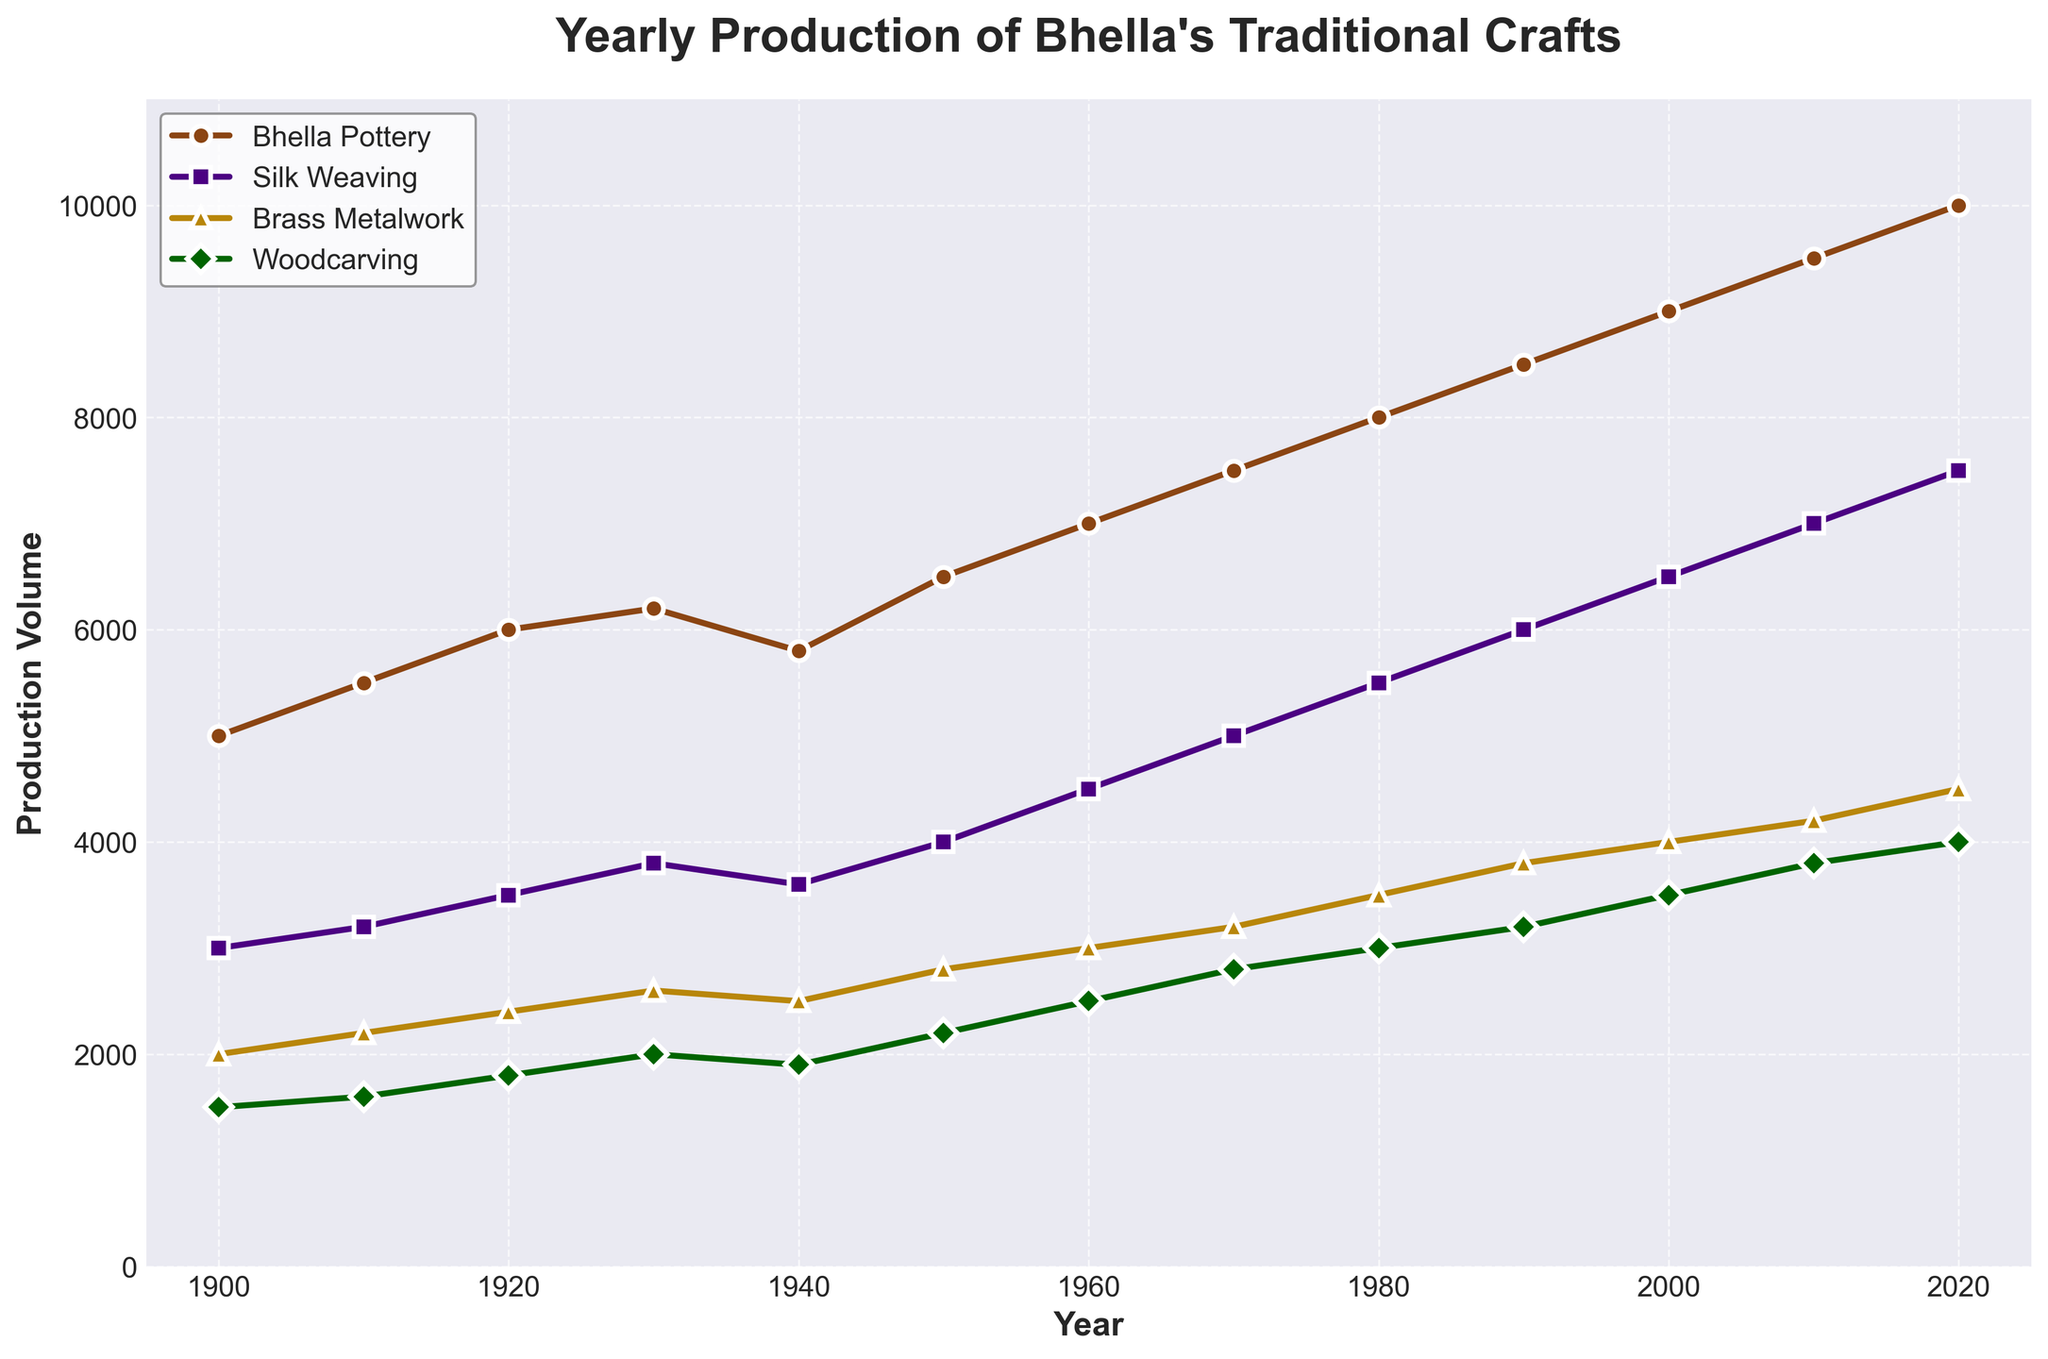How has the production volume of Bhella Pottery changed from 1900 to 2020? To find this, look at the Bhella Pottery data points for the years 1900 and 2020. In 1900, the production volume is 5,000, while in 2020, it is 10,000. Thus, it has doubled over 120 years.
Answer: It has doubled Which traditional craft had the highest production volume in 2020? To answer this, observe the data points in 2020 for all the crafts. Bhella Pottery (10,000) is the highest among Bhella Pottery (10,000), Silk Weaving (7,500), Brass Metalwork (4,500), and Woodcarving (4,000).
Answer: Bhella Pottery Between which consecutive decades did Bhella Pottery see the highest increase in production volume? Look at the differences between the production volumes of Bhella Pottery for each consecutive decade. The highest increase is from 1940 (5800) to 1950 (6500), which is an increase of 700 units.
Answer: Between 1940 and 1950 What's the difference in production volume between Silk Weaving and Brass Metalwork in 1980? Find the production values for Silk Weaving (5,500) and Brass Metalwork (3,500) in 1980. Subtract Brass Metalwork from Silk Weaving: 5500 - 3500 = 2000.
Answer: 2000 Is Woodcarving’s production volume in 2000 greater than its volume in 1960? Compare the production volumes of Woodcarving in 2000 (3,500) and 1960 (2,500). Since 3,500 > 2,500, the answer is yes.
Answer: Yes Which traditional craft showed the least growth in production volume from 1900 to 2020? Calculate the difference in production volumes from 1900 to 2020 for each craft. The lowest growth is in Woodcarving with an increase of 2,500 (from 1500 to 4000).
Answer: Woodcarving What is the average production volume of Silk Weaving from 1900 to 2020? Sum the production values for Silk Weaving from 1900 (3,000) to 2020 (7,500) and divide by the number of data points (13). The total sum is 62,200, and the average is 62,200 / 13 ≈ 4,785.
Answer: 4,785 By how much did the production volume of Brass Metalwork change between 1970 and 2010? Subtract the 1970 value of Brass Metalwork (3,200) from the 2010 value (4,200). The difference is 4200 - 3200 = 1000.
Answer: 1000 What trend can you observe in the production volume of all four crafts over the years? Observe the general upward trend in the production volumes of all four crafts from 1900 to 2020, with occasional small declines or plateaus.
Answer: An overall increase In what decade did both Silk Weaving and Woodcarving experience a dip in production volume? Identify the years where both Silk Weaving and Woodcarving show a decrease from the previous decade. Both experienced a dip between 1930 and 1940.
Answer: 1940s 